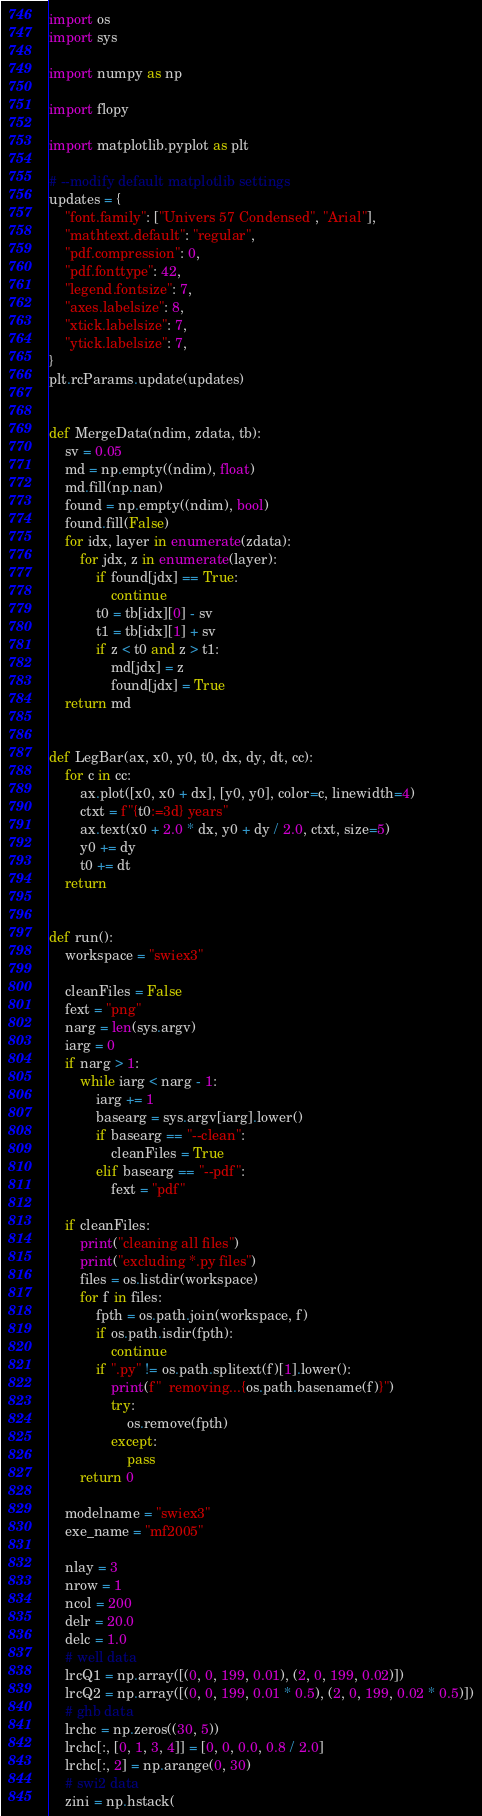Convert code to text. <code><loc_0><loc_0><loc_500><loc_500><_Python_>import os
import sys

import numpy as np

import flopy

import matplotlib.pyplot as plt

# --modify default matplotlib settings
updates = {
    "font.family": ["Univers 57 Condensed", "Arial"],
    "mathtext.default": "regular",
    "pdf.compression": 0,
    "pdf.fonttype": 42,
    "legend.fontsize": 7,
    "axes.labelsize": 8,
    "xtick.labelsize": 7,
    "ytick.labelsize": 7,
}
plt.rcParams.update(updates)


def MergeData(ndim, zdata, tb):
    sv = 0.05
    md = np.empty((ndim), float)
    md.fill(np.nan)
    found = np.empty((ndim), bool)
    found.fill(False)
    for idx, layer in enumerate(zdata):
        for jdx, z in enumerate(layer):
            if found[jdx] == True:
                continue
            t0 = tb[idx][0] - sv
            t1 = tb[idx][1] + sv
            if z < t0 and z > t1:
                md[jdx] = z
                found[jdx] = True
    return md


def LegBar(ax, x0, y0, t0, dx, dy, dt, cc):
    for c in cc:
        ax.plot([x0, x0 + dx], [y0, y0], color=c, linewidth=4)
        ctxt = f"{t0:=3d} years"
        ax.text(x0 + 2.0 * dx, y0 + dy / 2.0, ctxt, size=5)
        y0 += dy
        t0 += dt
    return


def run():
    workspace = "swiex3"

    cleanFiles = False
    fext = "png"
    narg = len(sys.argv)
    iarg = 0
    if narg > 1:
        while iarg < narg - 1:
            iarg += 1
            basearg = sys.argv[iarg].lower()
            if basearg == "--clean":
                cleanFiles = True
            elif basearg == "--pdf":
                fext = "pdf"

    if cleanFiles:
        print("cleaning all files")
        print("excluding *.py files")
        files = os.listdir(workspace)
        for f in files:
            fpth = os.path.join(workspace, f)
            if os.path.isdir(fpth):
                continue
            if ".py" != os.path.splitext(f)[1].lower():
                print(f"  removing...{os.path.basename(f)}")
                try:
                    os.remove(fpth)
                except:
                    pass
        return 0

    modelname = "swiex3"
    exe_name = "mf2005"

    nlay = 3
    nrow = 1
    ncol = 200
    delr = 20.0
    delc = 1.0
    # well data
    lrcQ1 = np.array([(0, 0, 199, 0.01), (2, 0, 199, 0.02)])
    lrcQ2 = np.array([(0, 0, 199, 0.01 * 0.5), (2, 0, 199, 0.02 * 0.5)])
    # ghb data
    lrchc = np.zeros((30, 5))
    lrchc[:, [0, 1, 3, 4]] = [0, 0, 0.0, 0.8 / 2.0]
    lrchc[:, 2] = np.arange(0, 30)
    # swi2 data
    zini = np.hstack(</code> 